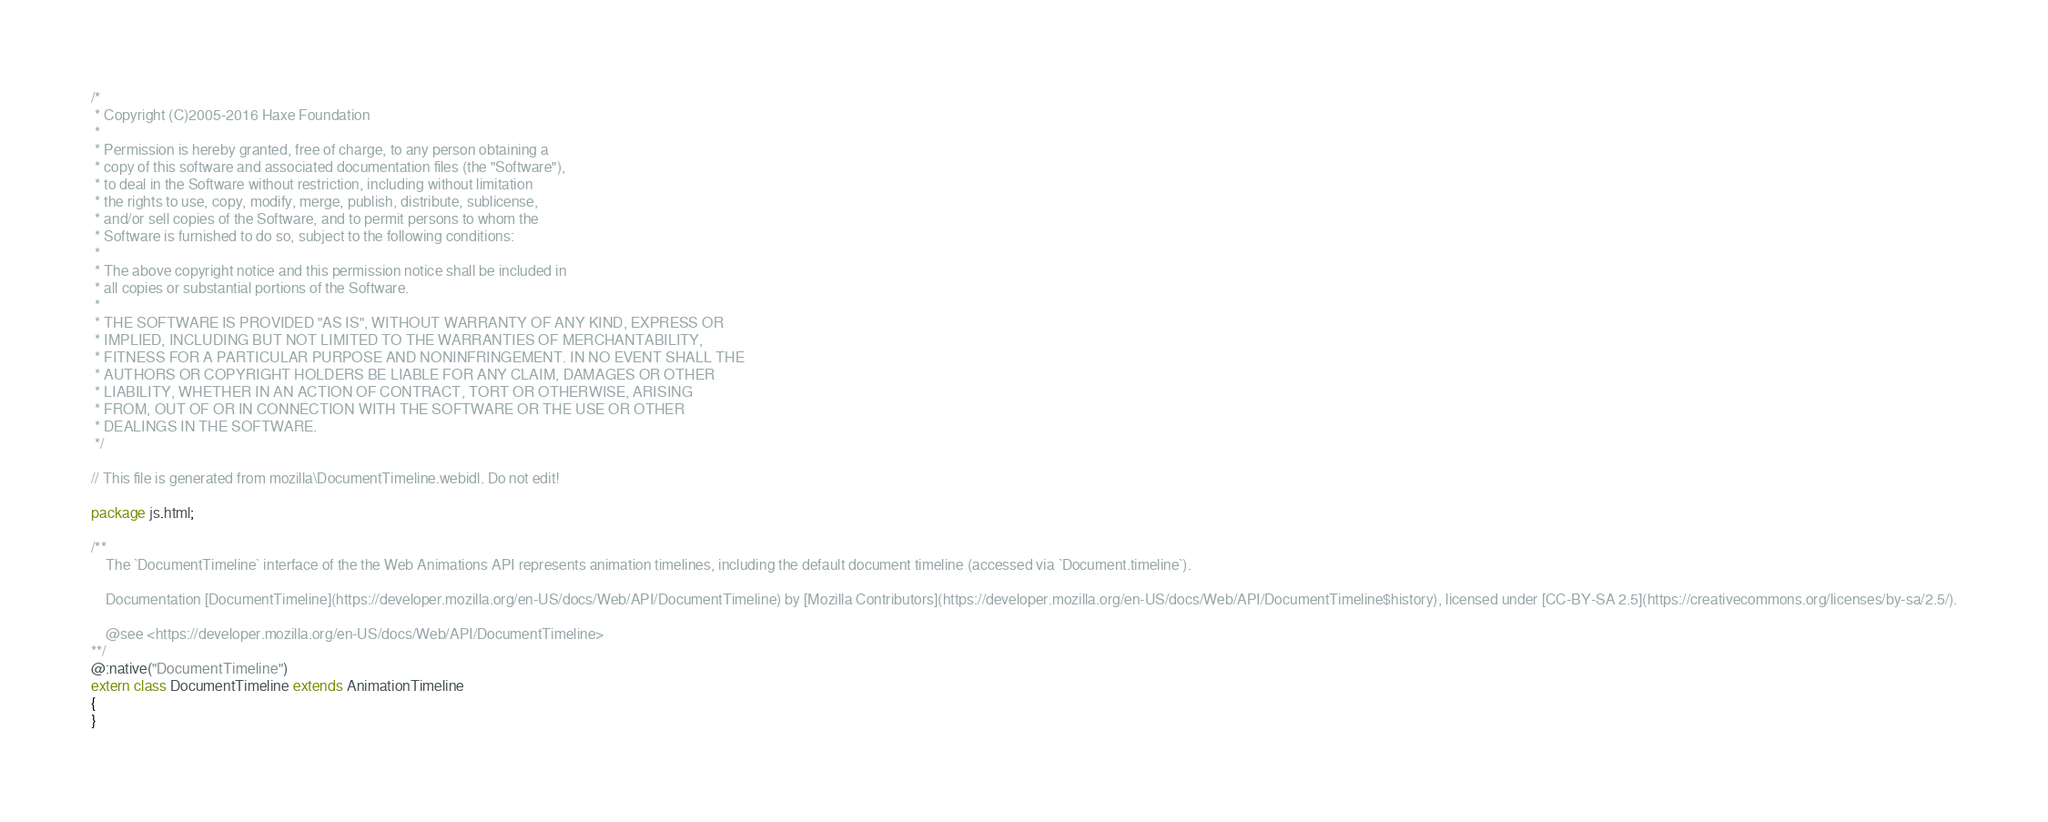Convert code to text. <code><loc_0><loc_0><loc_500><loc_500><_Haxe_>/*
 * Copyright (C)2005-2016 Haxe Foundation
 *
 * Permission is hereby granted, free of charge, to any person obtaining a
 * copy of this software and associated documentation files (the "Software"),
 * to deal in the Software without restriction, including without limitation
 * the rights to use, copy, modify, merge, publish, distribute, sublicense,
 * and/or sell copies of the Software, and to permit persons to whom the
 * Software is furnished to do so, subject to the following conditions:
 *
 * The above copyright notice and this permission notice shall be included in
 * all copies or substantial portions of the Software.
 *
 * THE SOFTWARE IS PROVIDED "AS IS", WITHOUT WARRANTY OF ANY KIND, EXPRESS OR
 * IMPLIED, INCLUDING BUT NOT LIMITED TO THE WARRANTIES OF MERCHANTABILITY,
 * FITNESS FOR A PARTICULAR PURPOSE AND NONINFRINGEMENT. IN NO EVENT SHALL THE
 * AUTHORS OR COPYRIGHT HOLDERS BE LIABLE FOR ANY CLAIM, DAMAGES OR OTHER
 * LIABILITY, WHETHER IN AN ACTION OF CONTRACT, TORT OR OTHERWISE, ARISING
 * FROM, OUT OF OR IN CONNECTION WITH THE SOFTWARE OR THE USE OR OTHER
 * DEALINGS IN THE SOFTWARE.
 */

// This file is generated from mozilla\DocumentTimeline.webidl. Do not edit!

package js.html;

/**
	The `DocumentTimeline` interface of the the Web Animations API represents animation timelines, including the default document timeline (accessed via `Document.timeline`).

	Documentation [DocumentTimeline](https://developer.mozilla.org/en-US/docs/Web/API/DocumentTimeline) by [Mozilla Contributors](https://developer.mozilla.org/en-US/docs/Web/API/DocumentTimeline$history), licensed under [CC-BY-SA 2.5](https://creativecommons.org/licenses/by-sa/2.5/).

	@see <https://developer.mozilla.org/en-US/docs/Web/API/DocumentTimeline>
**/
@:native("DocumentTimeline")
extern class DocumentTimeline extends AnimationTimeline
{
}</code> 